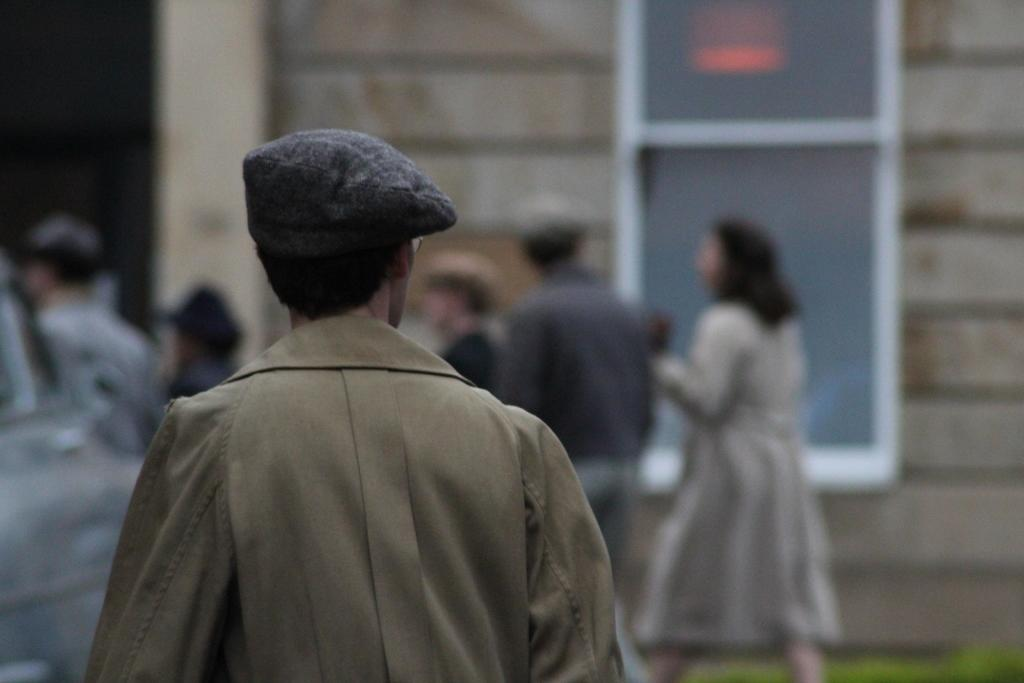How many people are in the group depicted in the image? There is a group of people in the image, but the exact number is not specified. What is the person in the group wearing that stands out? One person in the group is wearing a brown dress. What can be seen in the background of the image? There is a building in the background of the image. What is the color of the building in the image? The building is gray in color. Can you see any sea creatures in the image? There is no sea or sea creatures present in the image. What type of animals can be seen in the zoo in the image? There is no zoo or animals present in the image. 